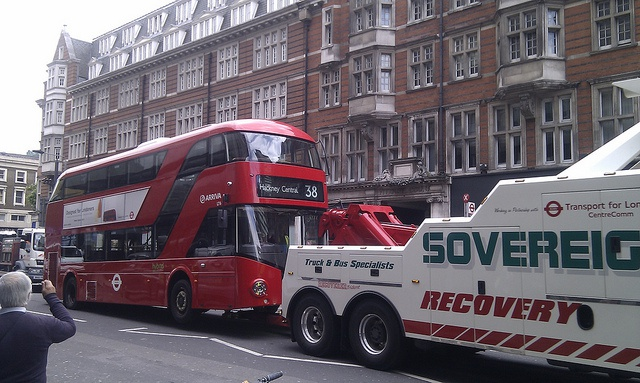Describe the objects in this image and their specific colors. I can see truck in white, gray, black, and maroon tones, bus in white, black, maroon, gray, and darkgray tones, people in white, black, gray, and darkgray tones, and truck in white, gray, darkgray, and black tones in this image. 